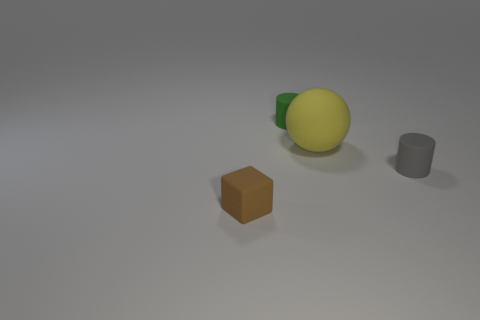Add 4 large yellow objects. How many objects exist? 8 Subtract all green cylinders. How many cylinders are left? 1 Subtract all purple cylinders. Subtract all gray blocks. How many cylinders are left? 2 Add 2 tiny yellow metallic balls. How many tiny yellow metallic balls exist? 2 Subtract 0 cyan blocks. How many objects are left? 4 Subtract all spheres. How many objects are left? 3 Subtract all big things. Subtract all tiny gray things. How many objects are left? 2 Add 3 large balls. How many large balls are left? 4 